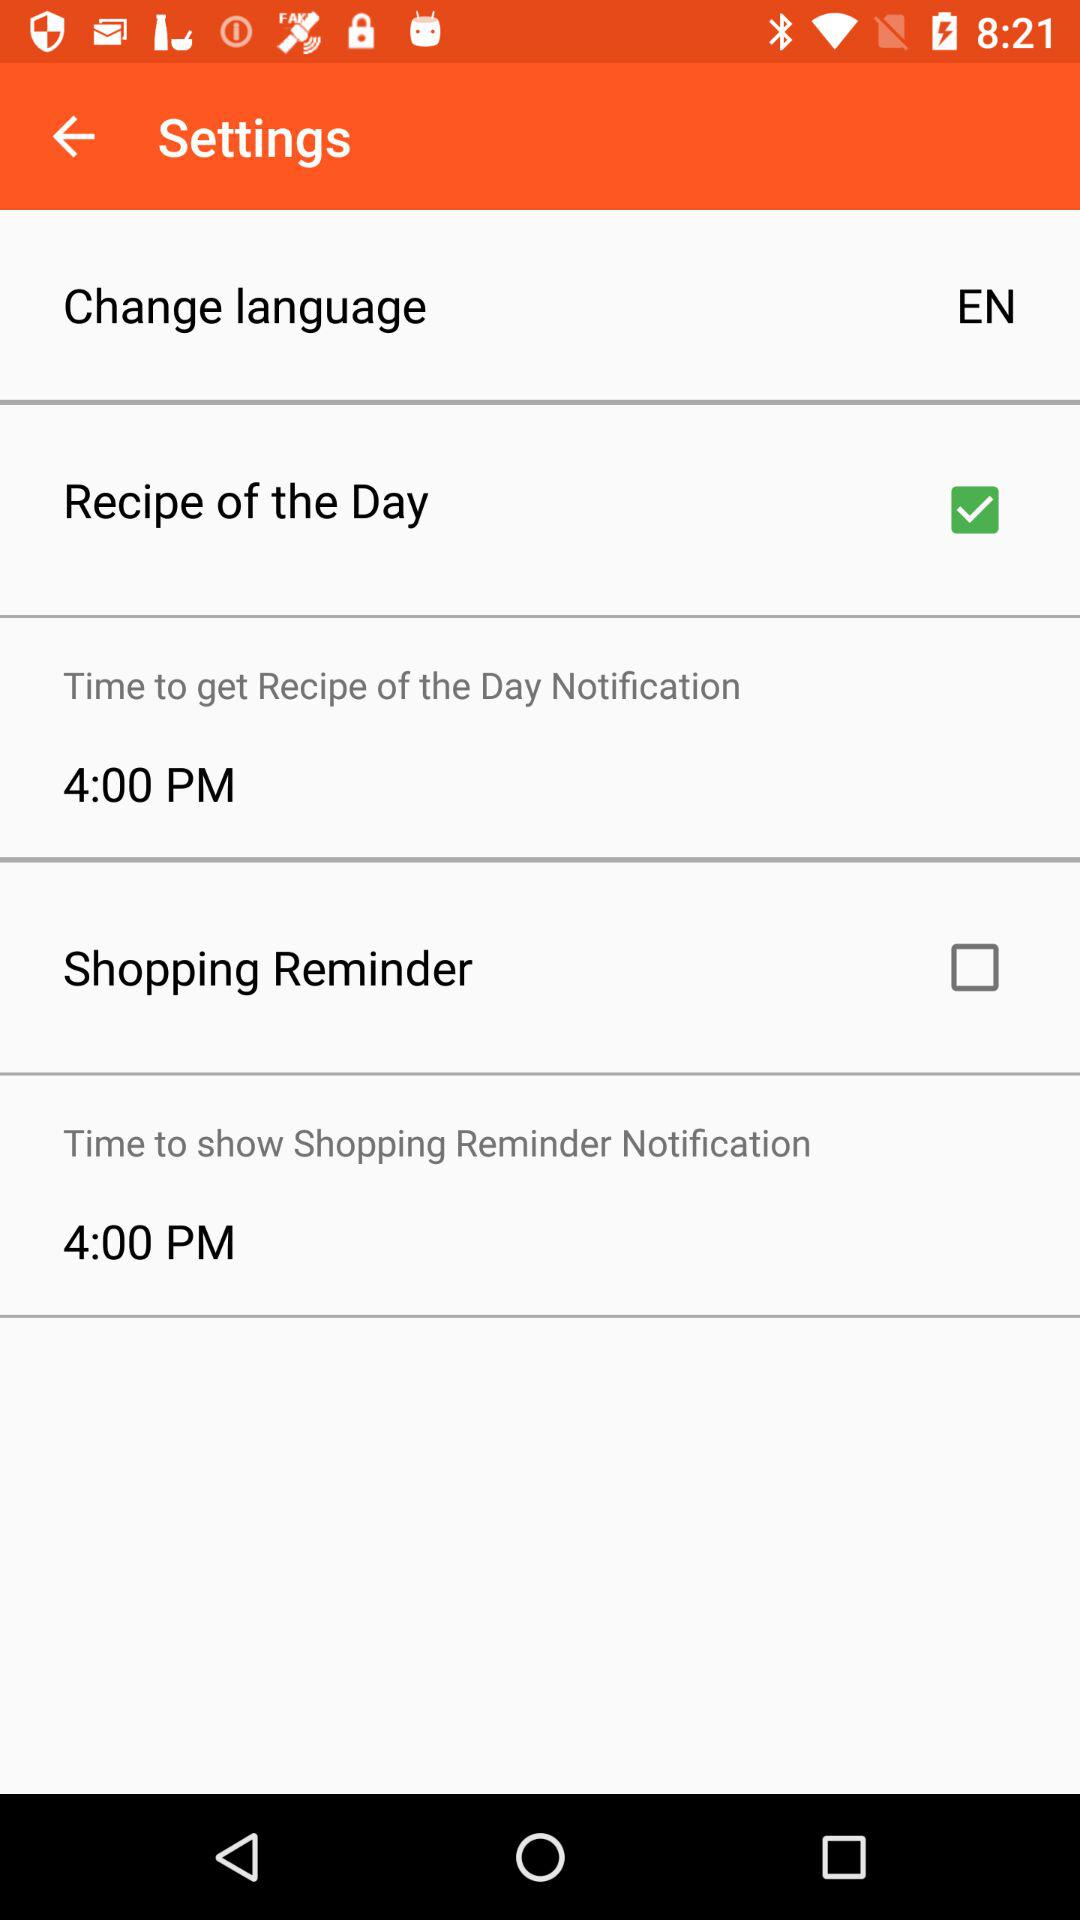How many notifications do I have set up?
Answer the question using a single word or phrase. 2 